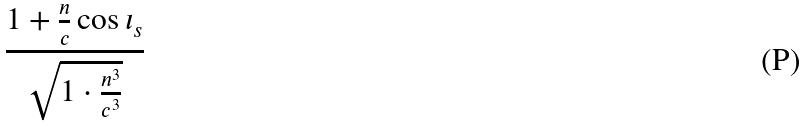<formula> <loc_0><loc_0><loc_500><loc_500>\frac { 1 + \frac { n } { c } \cos \iota _ { s } } { \sqrt { 1 \cdot \frac { n ^ { 3 } } { c ^ { 3 } } } }</formula> 